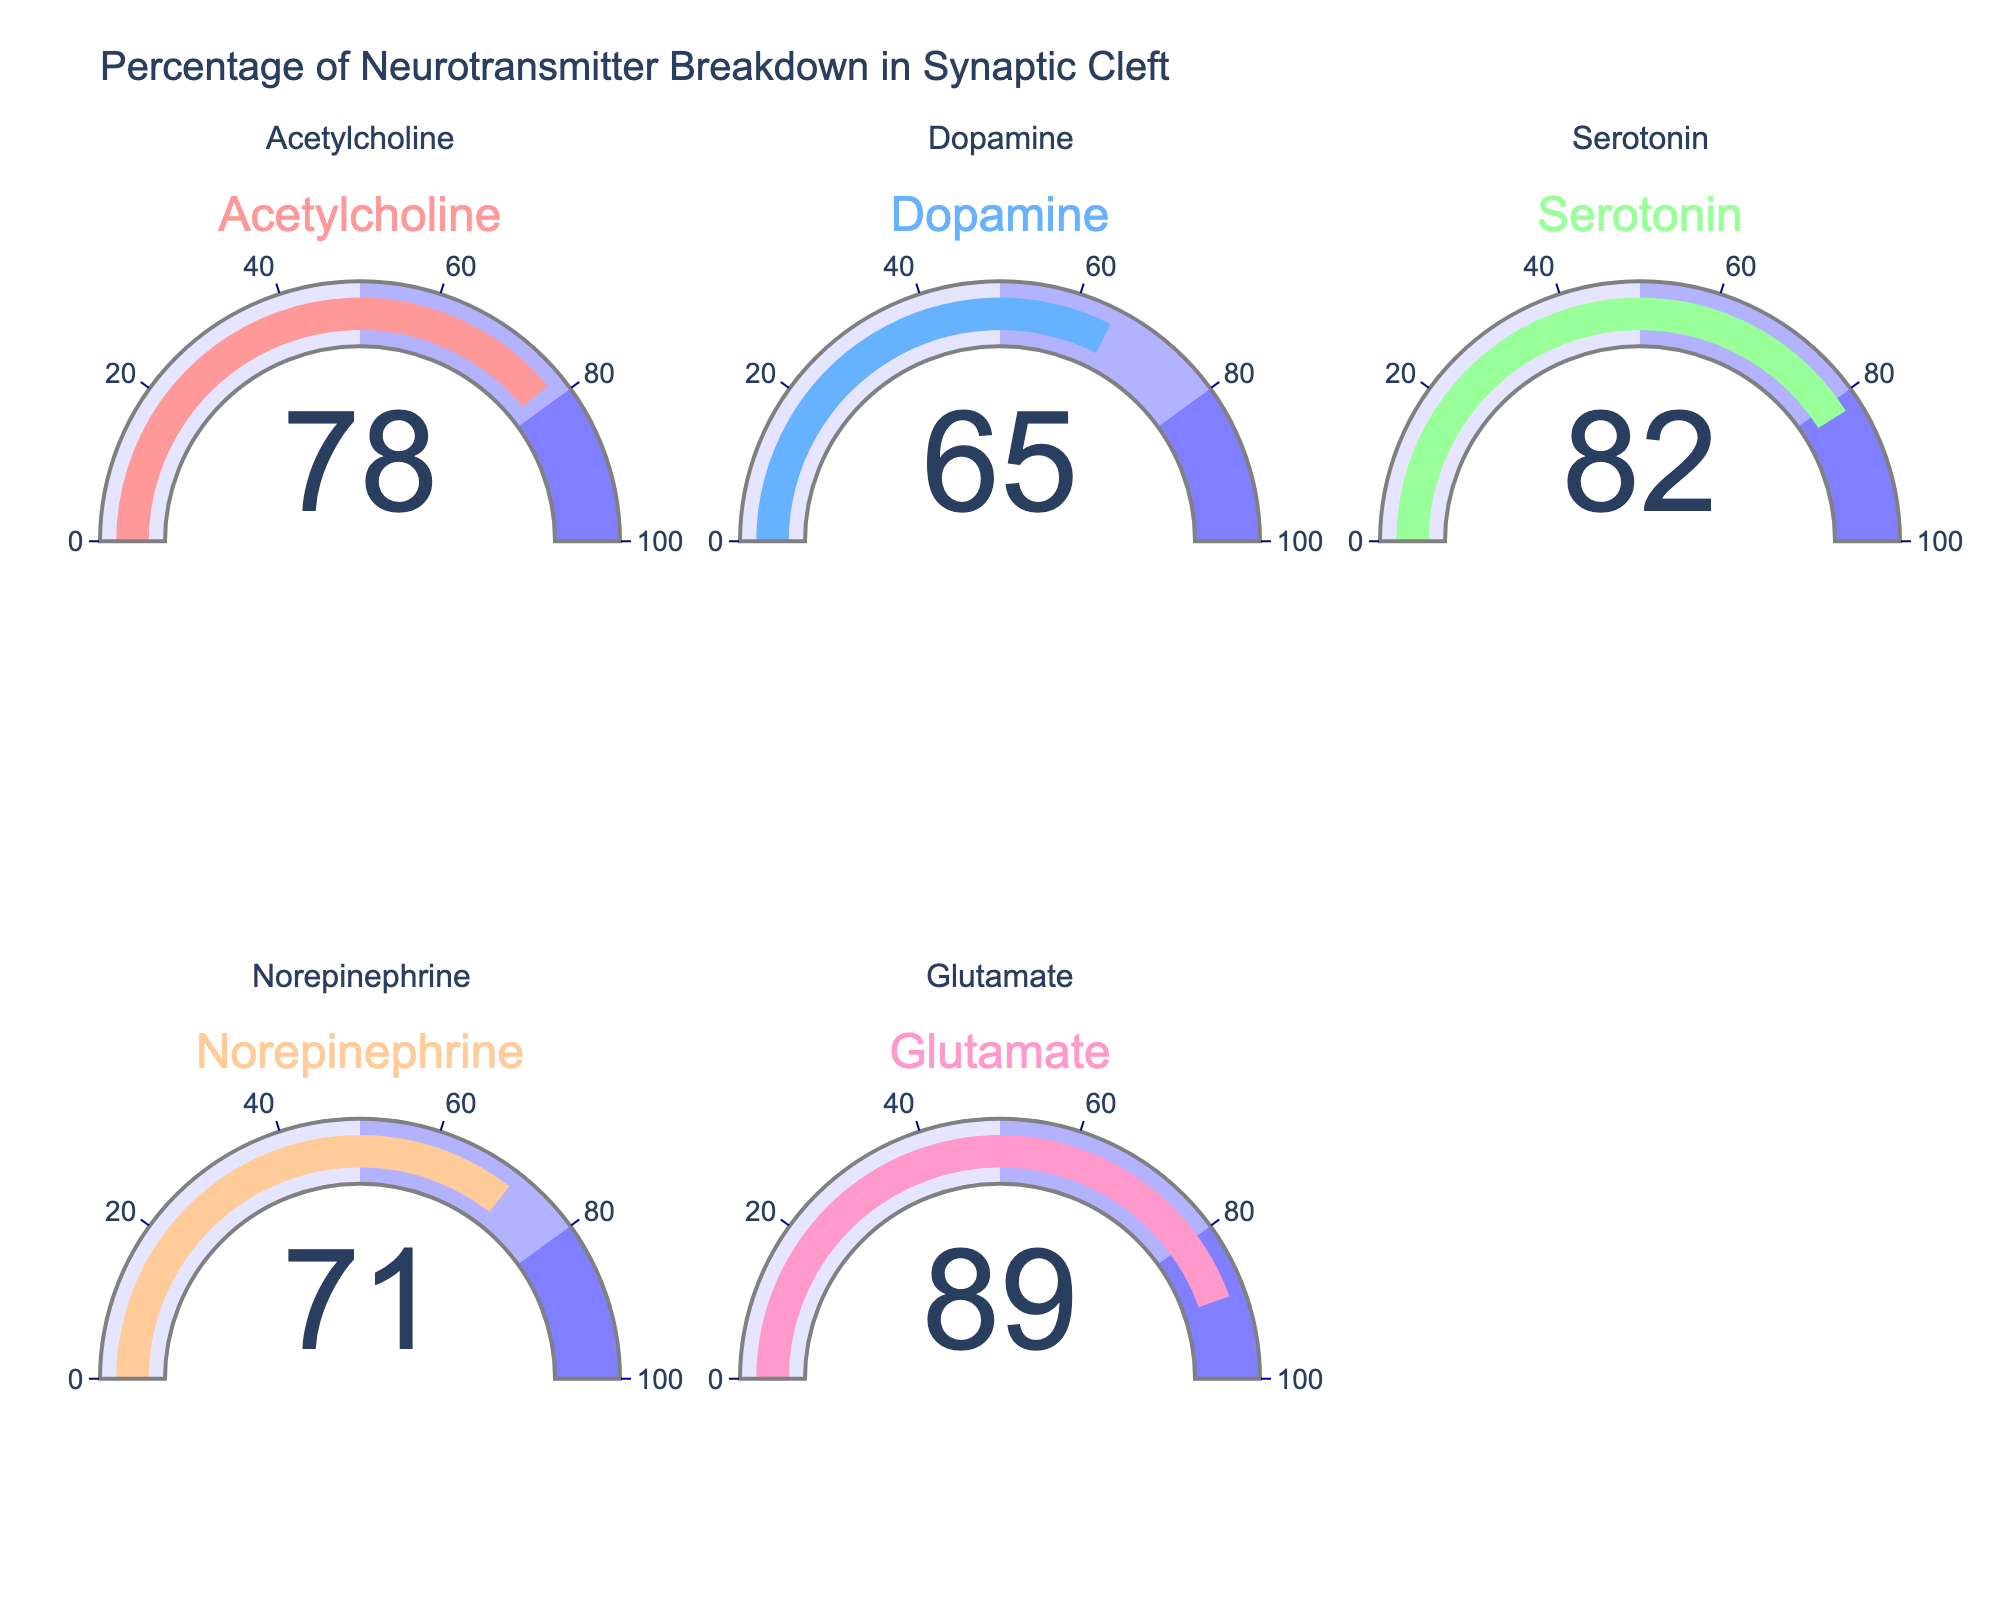What is the title of the figure? The title of the figure can be found at the top and it summarizes the content of the chart. The title is "Percentage of Neurotransmitter Breakdown in Synaptic Cleft"
Answer: Percentage of Neurotransmitter Breakdown in Synaptic Cleft How many neurotransmitters are displayed in the figure? Each gauge chart represents a neurotransmitter, and there are five individual gauges.
Answer: Five Which neurotransmitter has the highest breakdown percentage? By looking at the numbers displayed on each gauge, identify the largest percentage value. Glutamate's gauge shows 89%, which is the highest.
Answer: Glutamate Compare Acetylcholine and Dopamine breakdown percentages. Which one is higher and what is the difference between them? Acetylcholine has a breakdown percentage of 78%, while Dopamine has 65%. Acetylcholine is higher and to find the difference, subtract Dopamine's percentage from Acetylcholine's percentage: 78% - 65% = 13%.
Answer: Acetylcholine, 13% What is the average breakdown percentage of all neurotransmitters shown? Add up the breakdown percentages of all neurotransmitters: 78% (Acetylcholine) + 65% (Dopamine) + 82% (Serotonin) + 71% (Norepinephrine) + 89% (Glutamate). The sum is 385%. Divide this by 5 (the number of data points) to find the average: 385% / 5 = 77%.
Answer: 77% Which neurotransmitters have a breakdown percentage greater than 70%? Look at each gauge and identify the neurotransmitters with breakdown percentages above 70%. They are Acetylcholine (78%), Serotonin (82%), Norepinephrine (71%), and Glutamate (89%).
Answer: Acetylcholine, Serotonin, Norepinephrine, Glutamate Which gauge has the lowest value, and what is this value? Identify the gauge with the lowest percentage displayed. Dopamine's gauge shows 65%, which is the lowest value among all gauges.
Answer: Dopamine, 65% If we categorize breakdown percentages into two groups: above 80% and 80% or below, how many neurotransmitters fall into each group? Identify the percentages above 80%: Serotonin (82%) and Glutamate (89%), which are two neurotransmitters. For 80% or below, count the remaining: Acetylcholine (78%), Dopamine (65%), and Norepinephrine (71%), which are three neurotransmitters.
Answer: Above 80%: 2, 80% or below: 3 What is the range of neurotransmitter breakdown percentages displayed? Determine the highest and lowest values, which are Glutamate at 89% and Dopamine at 65%. The range is calculated as the difference between the highest and lowest values: 89% - 65% = 24%.
Answer: 24% What is the median breakdown percentage of the neurotransmitters? To find the median, list the percentages in order: 65%, 71%, 78%, 82%, and 89%. The median is the middle value, which is 78%.
Answer: 78% 